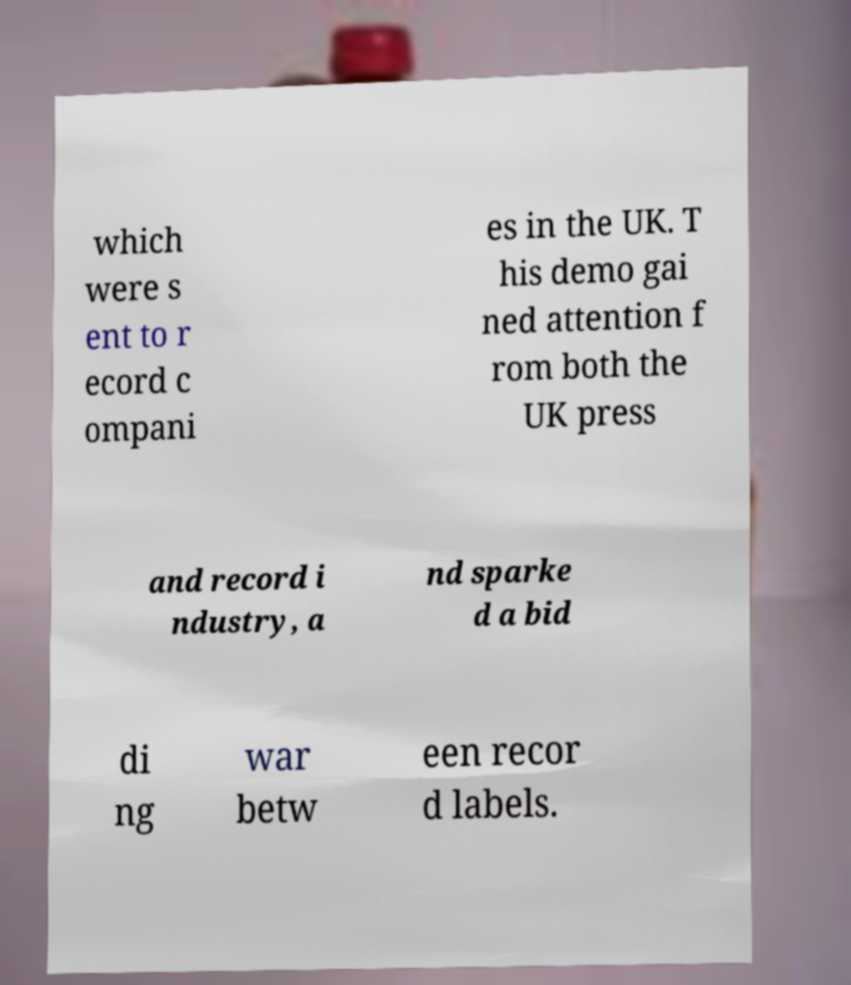For documentation purposes, I need the text within this image transcribed. Could you provide that? which were s ent to r ecord c ompani es in the UK. T his demo gai ned attention f rom both the UK press and record i ndustry, a nd sparke d a bid di ng war betw een recor d labels. 